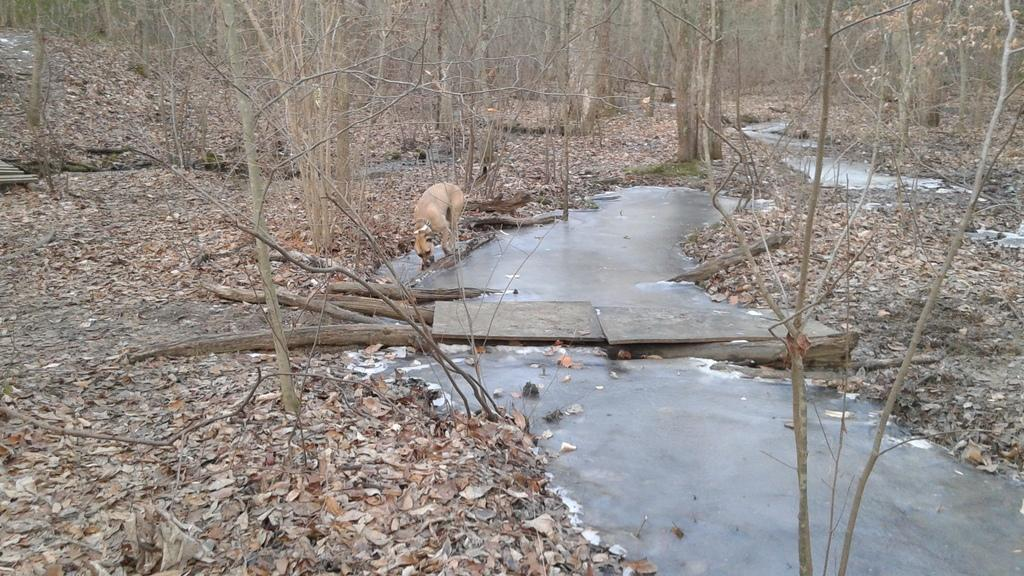What is one of the natural elements visible in the image? Water is visible in the image. What type of plant material can be seen in the image? Dry leaves are present in the image. What type of vegetation is in the image? There are trees in the image. What animal is in the middle of the image? There is a dog in the middle of the image. What type of jail can be seen in the image? There is no jail present in the image. What arithmetic problem is the dog solving in the image? The image does not depict the dog solving any arithmetic problem. 